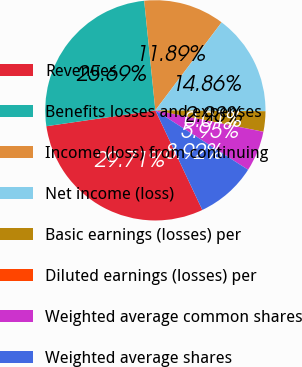Convert chart to OTSL. <chart><loc_0><loc_0><loc_500><loc_500><pie_chart><fcel>Revenues<fcel>Benefits losses and expenses<fcel>Income (loss) from continuing<fcel>Net income (loss)<fcel>Basic earnings (losses) per<fcel>Diluted earnings (losses) per<fcel>Weighted average common shares<fcel>Weighted average shares<nl><fcel>29.71%<fcel>25.69%<fcel>11.89%<fcel>14.86%<fcel>2.98%<fcel>0.01%<fcel>5.95%<fcel>8.92%<nl></chart> 